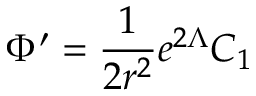<formula> <loc_0><loc_0><loc_500><loc_500>\Phi ^ { \prime } = \frac { 1 } { 2 r ^ { 2 } } e ^ { 2 \Lambda } C _ { 1 }</formula> 